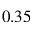<formula> <loc_0><loc_0><loc_500><loc_500>0 . 3 5</formula> 